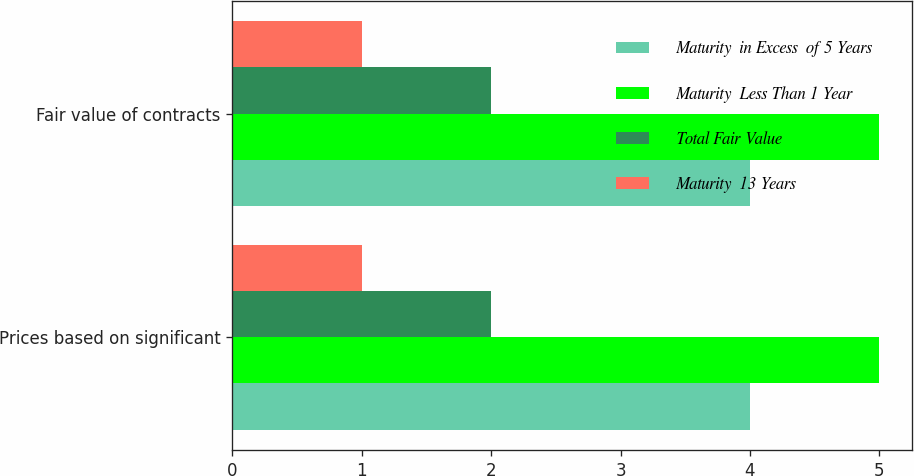<chart> <loc_0><loc_0><loc_500><loc_500><stacked_bar_chart><ecel><fcel>Prices based on significant<fcel>Fair value of contracts<nl><fcel>Maturity  in Excess  of 5 Years<fcel>4<fcel>4<nl><fcel>Maturity  Less Than 1 Year<fcel>5<fcel>5<nl><fcel>Total Fair Value<fcel>2<fcel>2<nl><fcel>Maturity  13 Years<fcel>1<fcel>1<nl></chart> 